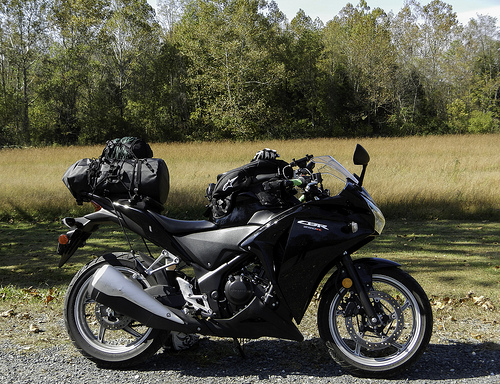<image>
Is the bike in front of the tree? Yes. The bike is positioned in front of the tree, appearing closer to the camera viewpoint. 